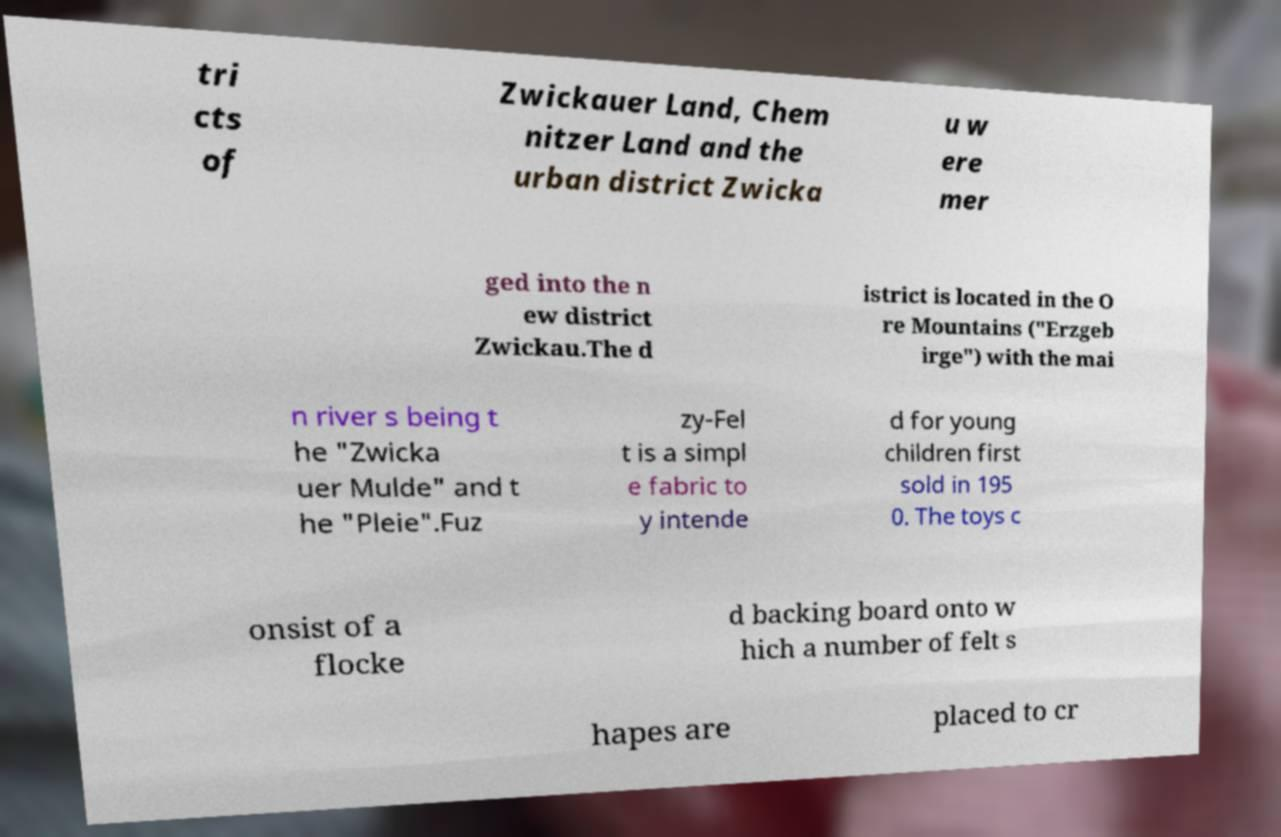Could you assist in decoding the text presented in this image and type it out clearly? tri cts of Zwickauer Land, Chem nitzer Land and the urban district Zwicka u w ere mer ged into the n ew district Zwickau.The d istrict is located in the O re Mountains ("Erzgeb irge") with the mai n river s being t he "Zwicka uer Mulde" and t he "Pleie".Fuz zy-Fel t is a simpl e fabric to y intende d for young children first sold in 195 0. The toys c onsist of a flocke d backing board onto w hich a number of felt s hapes are placed to cr 